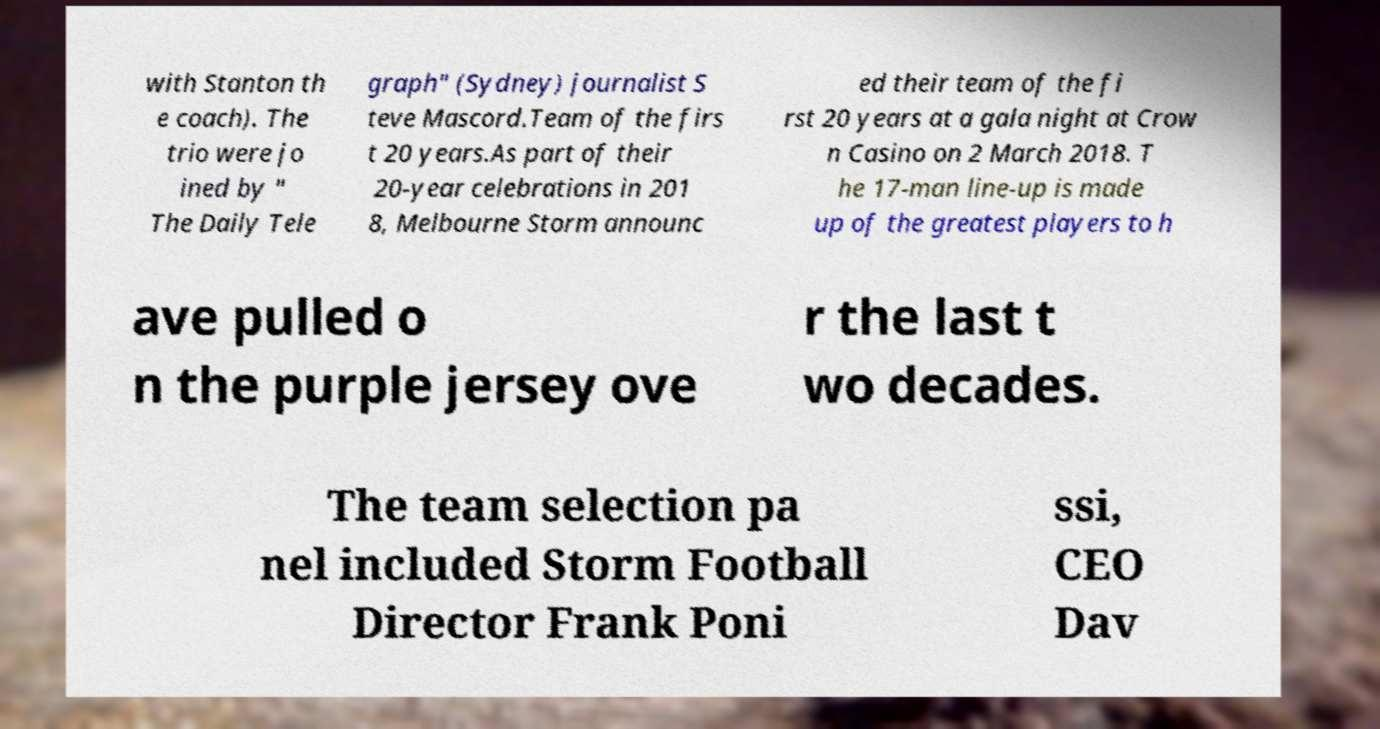There's text embedded in this image that I need extracted. Can you transcribe it verbatim? with Stanton th e coach). The trio were jo ined by " The Daily Tele graph" (Sydney) journalist S teve Mascord.Team of the firs t 20 years.As part of their 20-year celebrations in 201 8, Melbourne Storm announc ed their team of the fi rst 20 years at a gala night at Crow n Casino on 2 March 2018. T he 17-man line-up is made up of the greatest players to h ave pulled o n the purple jersey ove r the last t wo decades. The team selection pa nel included Storm Football Director Frank Poni ssi, CEO Dav 